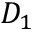Convert formula to latex. <formula><loc_0><loc_0><loc_500><loc_500>D _ { 1 }</formula> 